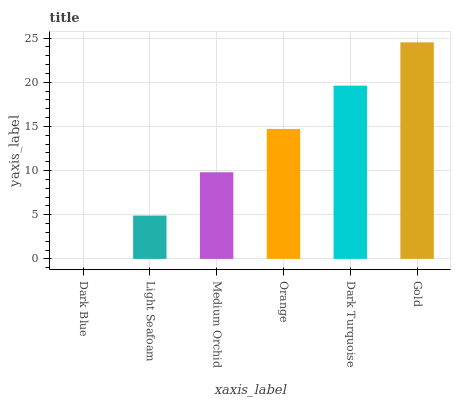Is Dark Blue the minimum?
Answer yes or no. Yes. Is Gold the maximum?
Answer yes or no. Yes. Is Light Seafoam the minimum?
Answer yes or no. No. Is Light Seafoam the maximum?
Answer yes or no. No. Is Light Seafoam greater than Dark Blue?
Answer yes or no. Yes. Is Dark Blue less than Light Seafoam?
Answer yes or no. Yes. Is Dark Blue greater than Light Seafoam?
Answer yes or no. No. Is Light Seafoam less than Dark Blue?
Answer yes or no. No. Is Orange the high median?
Answer yes or no. Yes. Is Medium Orchid the low median?
Answer yes or no. Yes. Is Gold the high median?
Answer yes or no. No. Is Gold the low median?
Answer yes or no. No. 